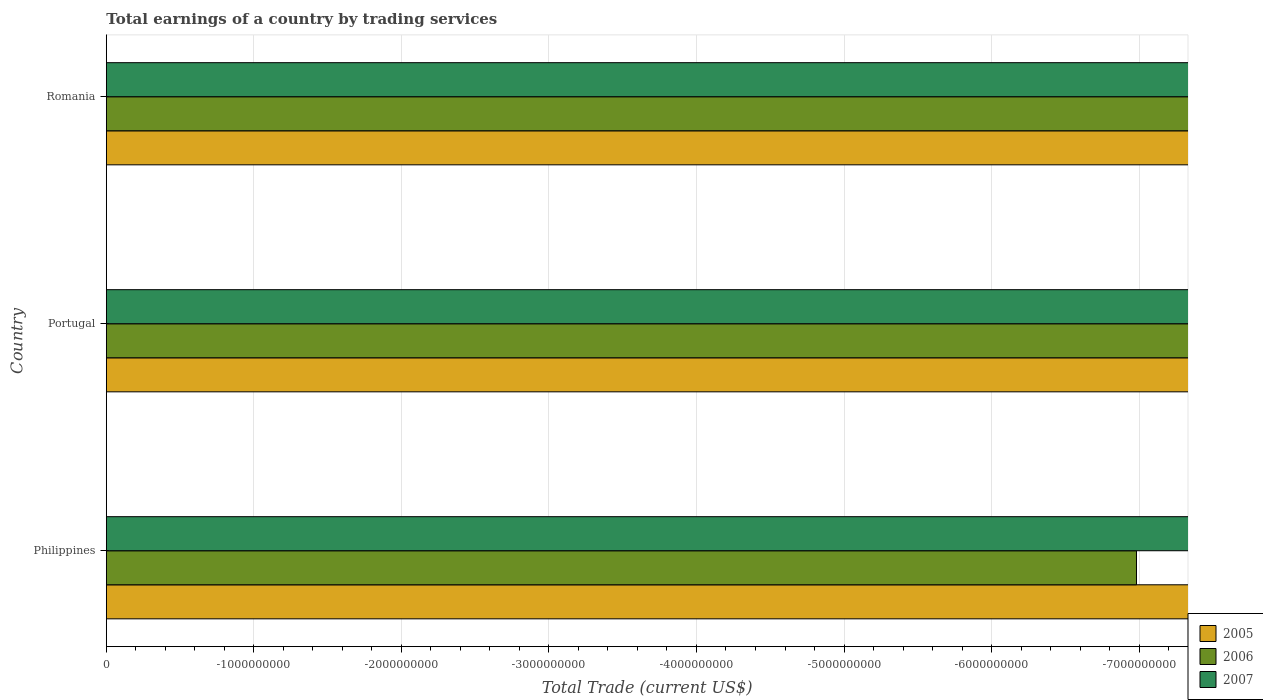Are the number of bars per tick equal to the number of legend labels?
Provide a short and direct response. No. Are the number of bars on each tick of the Y-axis equal?
Your answer should be very brief. Yes. How many bars are there on the 3rd tick from the top?
Make the answer very short. 0. How many bars are there on the 3rd tick from the bottom?
Your answer should be very brief. 0. What is the label of the 3rd group of bars from the top?
Offer a very short reply. Philippines. What is the total earnings in 2006 in Philippines?
Your response must be concise. 0. Across all countries, what is the minimum total earnings in 2006?
Your response must be concise. 0. What is the total total earnings in 2007 in the graph?
Provide a short and direct response. 0. What is the difference between the total earnings in 2007 in Romania and the total earnings in 2006 in Philippines?
Offer a very short reply. 0. What is the average total earnings in 2005 per country?
Give a very brief answer. 0. In how many countries, is the total earnings in 2005 greater than -6800000000 US$?
Make the answer very short. 0. How many bars are there?
Make the answer very short. 0. Does the graph contain grids?
Provide a short and direct response. Yes. How many legend labels are there?
Your response must be concise. 3. What is the title of the graph?
Give a very brief answer. Total earnings of a country by trading services. Does "2012" appear as one of the legend labels in the graph?
Your answer should be very brief. No. What is the label or title of the X-axis?
Offer a very short reply. Total Trade (current US$). What is the Total Trade (current US$) of 2005 in Philippines?
Provide a succinct answer. 0. What is the Total Trade (current US$) of 2006 in Philippines?
Offer a terse response. 0. What is the Total Trade (current US$) in 2005 in Portugal?
Your answer should be very brief. 0. What is the Total Trade (current US$) in 2007 in Portugal?
Offer a terse response. 0. What is the Total Trade (current US$) in 2005 in Romania?
Your answer should be compact. 0. What is the total Total Trade (current US$) of 2007 in the graph?
Your answer should be very brief. 0. What is the average Total Trade (current US$) of 2006 per country?
Make the answer very short. 0. What is the average Total Trade (current US$) of 2007 per country?
Your answer should be compact. 0. 